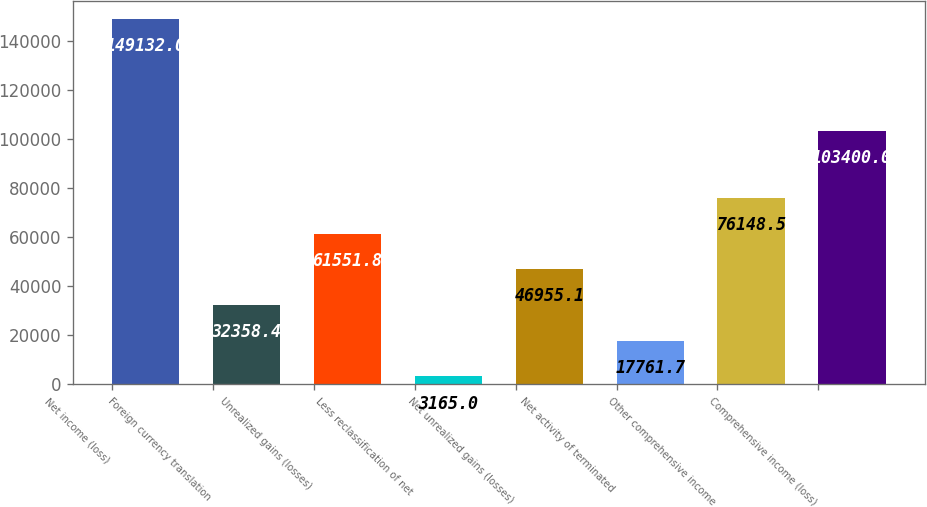<chart> <loc_0><loc_0><loc_500><loc_500><bar_chart><fcel>Net income (loss)<fcel>Foreign currency translation<fcel>Unrealized gains (losses)<fcel>Less reclassification of net<fcel>Net unrealized gains (losses)<fcel>Net activity of terminated<fcel>Other comprehensive income<fcel>Comprehensive income (loss)<nl><fcel>149132<fcel>32358.4<fcel>61551.8<fcel>3165<fcel>46955.1<fcel>17761.7<fcel>76148.5<fcel>103400<nl></chart> 